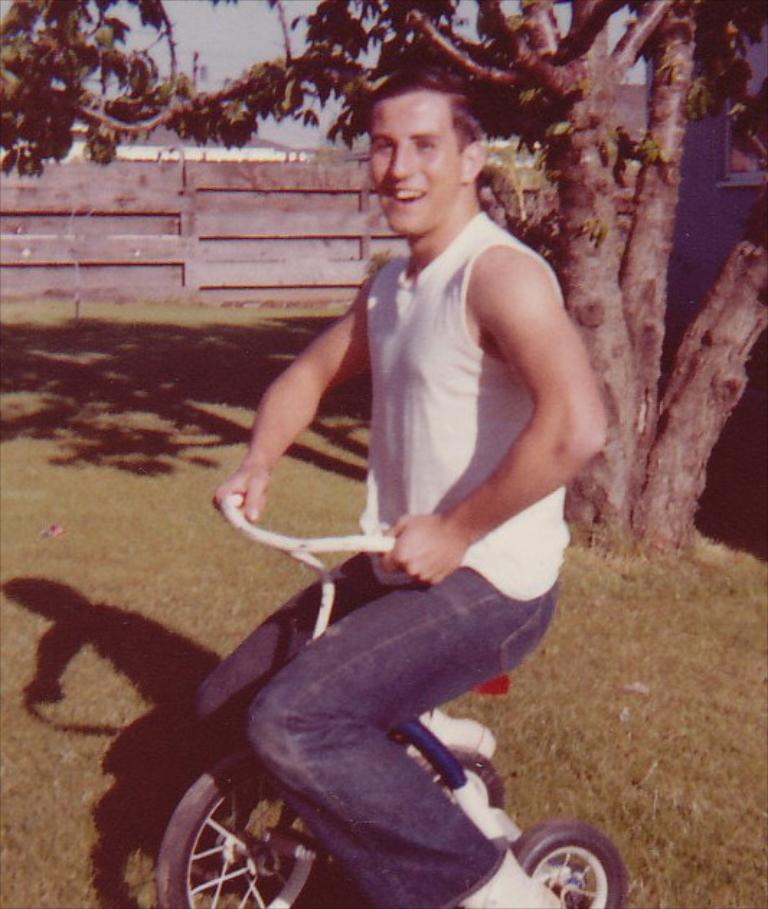What is the person in the image doing? The person is sitting on a bicycle in the image. What can be seen in the background of the image? There is a tree, grass, fencing, a building, and the sky visible in the background of the image. How many robins are perched on the bicycle in the image? There are no robins present in the image; it only features a person sitting on a bicycle. Can you describe the icicles hanging from the tree in the image? There are no icicles present in the image; the tree is in the background, but no specific details about the tree are mentioned. 